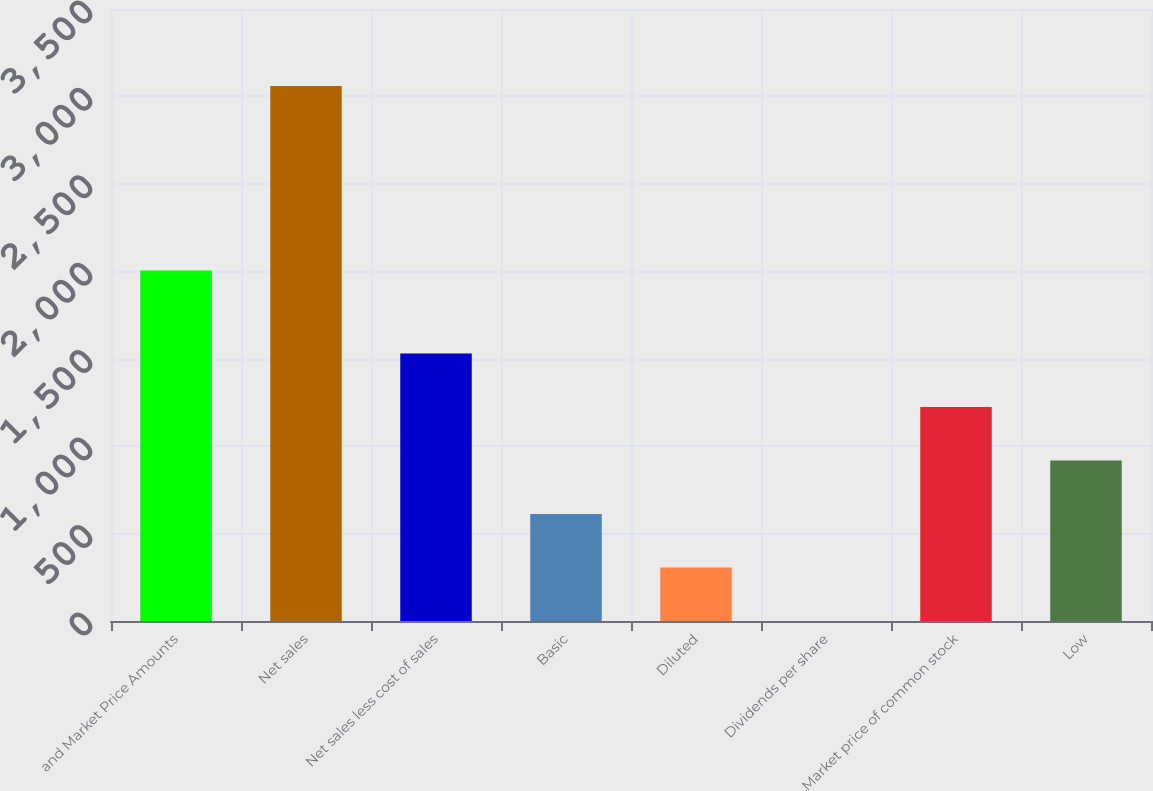Convert chart. <chart><loc_0><loc_0><loc_500><loc_500><bar_chart><fcel>and Market Price Amounts<fcel>Net sales<fcel>Net sales less cost of sales<fcel>Basic<fcel>Diluted<fcel>Dividends per share<fcel>Market price of common stock<fcel>Low<nl><fcel>2004<fcel>3060<fcel>1530.13<fcel>612.22<fcel>306.25<fcel>0.28<fcel>1224.16<fcel>918.19<nl></chart> 